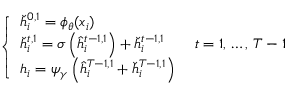<formula> <loc_0><loc_0><loc_500><loc_500>\begin{array} { r } { \left \{ \begin{array} { l l } { \check { h } _ { i } ^ { 0 , 1 } = \phi _ { \theta } ( x _ { i } ) } \\ { \check { h } _ { i } ^ { t , 1 } = \sigma \left ( \hat { h } _ { i } ^ { t - 1 , 1 } \right ) + \check { h } _ { i } ^ { t - 1 , 1 } \quad t = 1 , \, \dots , \, T - 1 } \\ { h _ { i } = \psi _ { \gamma } \left ( \hat { h } _ { i } ^ { T - 1 , 1 } + \check { h } _ { i } ^ { T - 1 , 1 } \right ) } \end{array} } \end{array}</formula> 